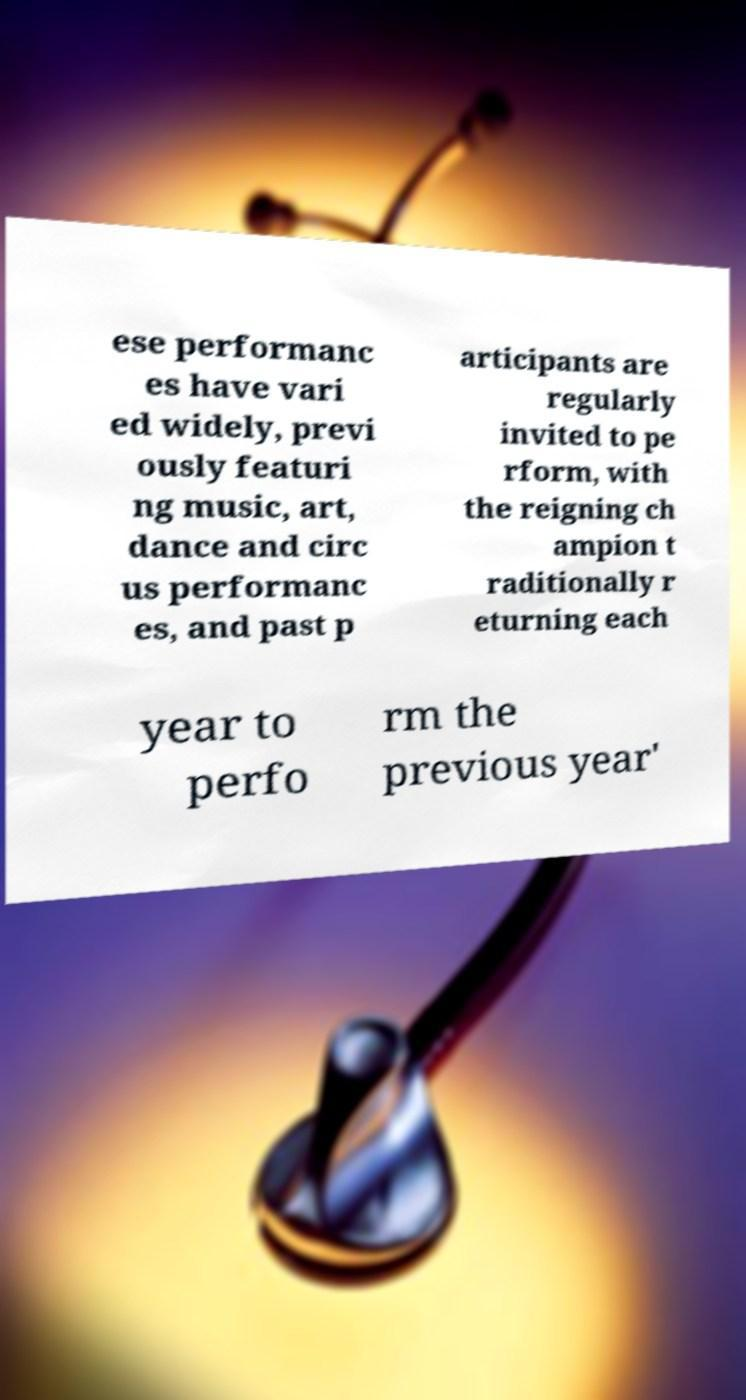Please read and relay the text visible in this image. What does it say? ese performanc es have vari ed widely, previ ously featuri ng music, art, dance and circ us performanc es, and past p articipants are regularly invited to pe rform, with the reigning ch ampion t raditionally r eturning each year to perfo rm the previous year' 